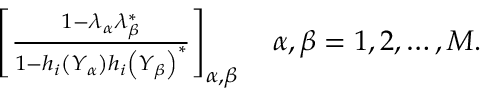Convert formula to latex. <formula><loc_0><loc_0><loc_500><loc_500>\begin{array} { r } { \left [ \frac { 1 - \lambda _ { \alpha } \lambda _ { \beta } ^ { * } } { 1 - h _ { i } \left ( Y _ { \alpha } \right ) h _ { i } \left ( Y _ { \beta } \right ) ^ { * } } \right ] _ { \alpha , \beta } \quad \alpha , \beta = 1 , 2 , \dots , M . } \end{array}</formula> 